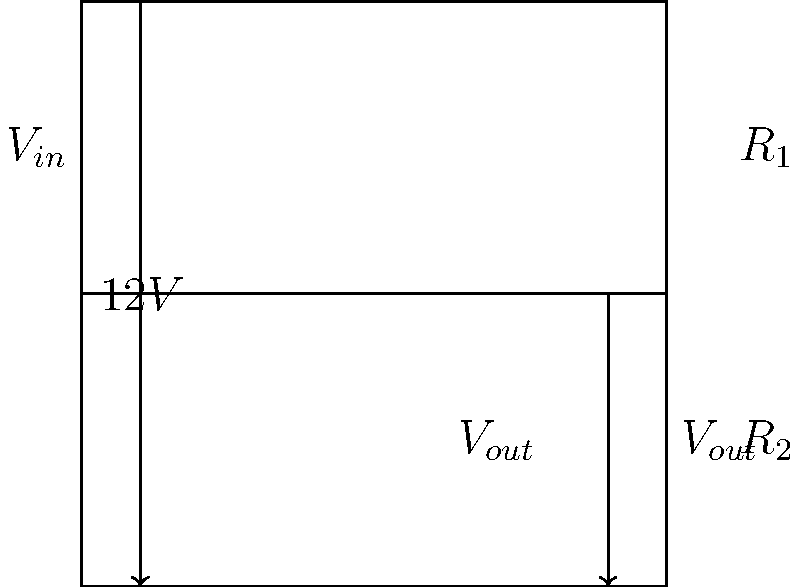In the context of asymmetric warfare, consider a voltage divider circuit as an analogy for resource distribution. Given a circuit with $V_{in} = 12V$, $R_1 = 1k\Omega$, and $R_2 = 3k\Omega$, calculate $V_{out}$. How might this relate to the allocation of resources in asymmetric conflicts? To solve this problem, we'll use the voltage divider formula and then draw an analogy to asymmetric warfare:

1) The voltage divider formula is:

   $$V_{out} = V_{in} \cdot \frac{R_2}{R_1 + R_2}$$

2) Substituting the given values:

   $$V_{out} = 12V \cdot \frac{3k\Omega}{1k\Omega + 3k\Omega}$$

3) Simplify:

   $$V_{out} = 12V \cdot \frac{3k\Omega}{4k\Omega} = 12V \cdot \frac{3}{4} = 9V$$

4) Analogy to asymmetric warfare:
   - $V_{in}$ represents the total resources available in a conflict.
   - $R_1$ and $R_2$ represent the relative strengths or capabilities of opposing forces.
   - $V_{out}$ represents the effective power or control exerted by the stronger force (R2).

In asymmetric warfare, the weaker force (analogous to R1) often employs unconventional tactics to overcome the resource advantage of the stronger force (R2). This circuit demonstrates how even with a significant imbalance in "resistance" (3:1 ratio), the weaker party still influences the overall "voltage" distribution, highlighting the complexity of power dynamics in asymmetric conflicts.
Answer: $V_{out} = 9V$ 